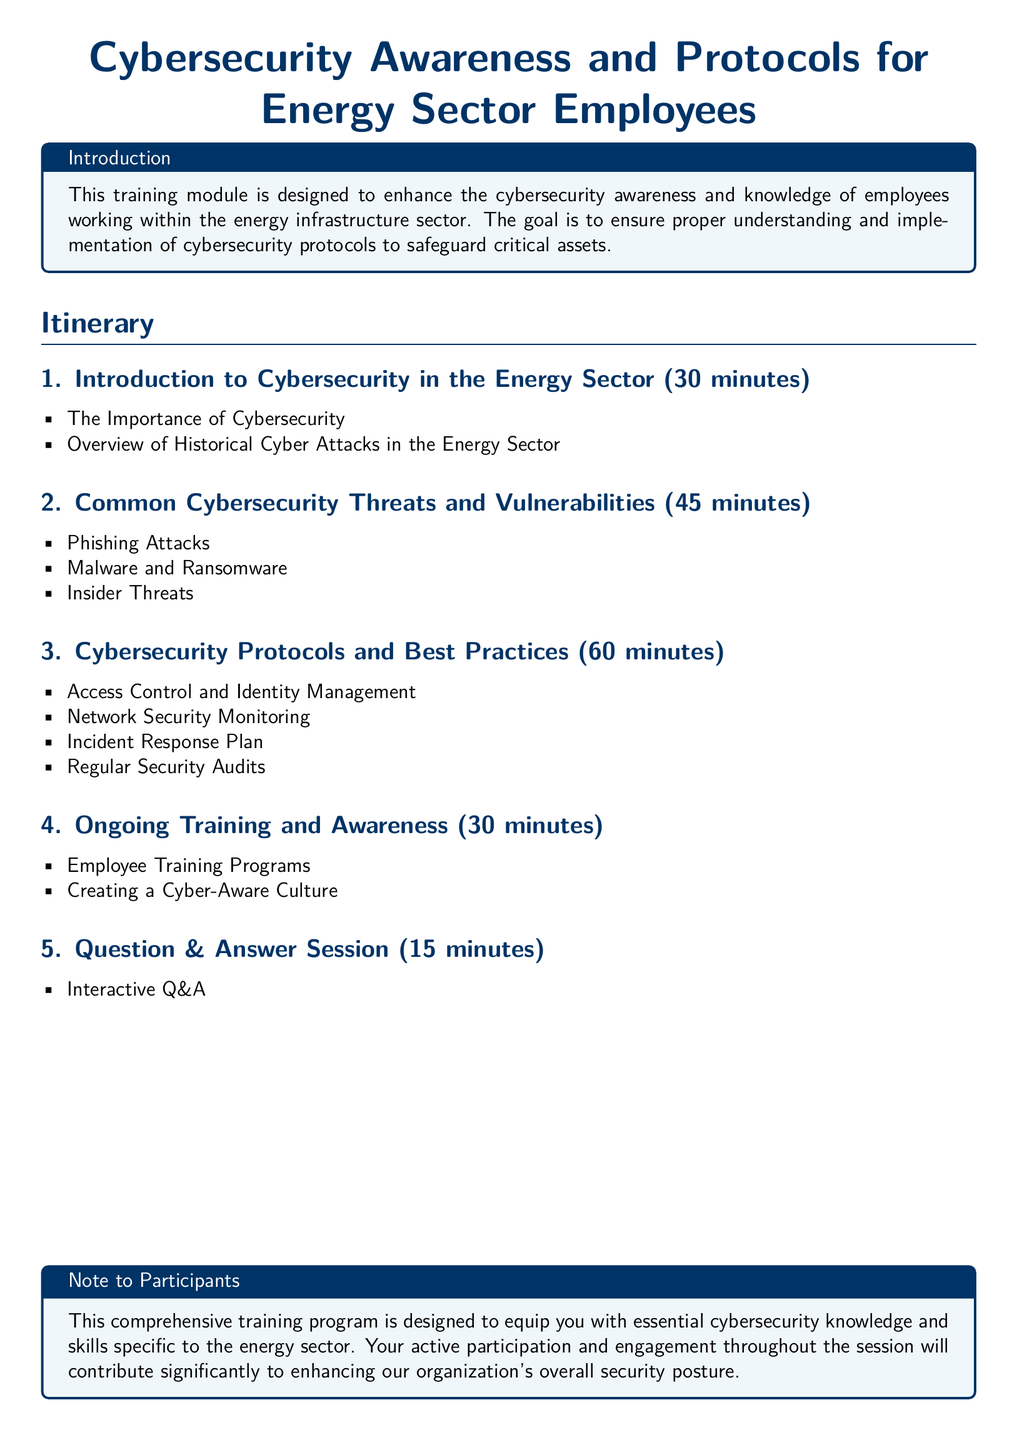What is the first topic covered in the training? The first topic listed in the itinerary is "Introduction to Cybersecurity in the Energy Sector."
Answer: Introduction to Cybersecurity in the Energy Sector How long is the cybersecurity protocols session? The document states that the session on cybersecurity protocols lasts for 60 minutes.
Answer: 60 minutes What is the focus of the ongoing training section? The ongoing training section emphasizes employee training programs and creating a cyber-aware culture.
Answer: Employee Training Programs How many minutes are allocated for the Q&A session? The itinerary specifies that the Q&A session is allotted 15 minutes.
Answer: 15 minutes What are two types of cybersecurity threats discussed? The document lists phishing attacks and malware & ransomware as common threats.
Answer: Phishing Attacks, Malware and Ransomware What is the main goal of the training module? The main goal is to enhance cybersecurity awareness and knowledge of employees in the energy sector.
Answer: Enhance cybersecurity awareness and knowledge Which aspect of cybersecurity involves regular checks? Regular security audits are mentioned as an important aspect of cybersecurity protocols.
Answer: Regular Security Audits What is the purpose of the training program as noted to participants? The training program is designed to equip participants with essential cybersecurity knowledge specific to the energy sector.
Answer: Equip with essential cybersecurity knowledge How many sections are there in the itinerary? There are five sections listed in the itinerary.
Answer: Five sections 